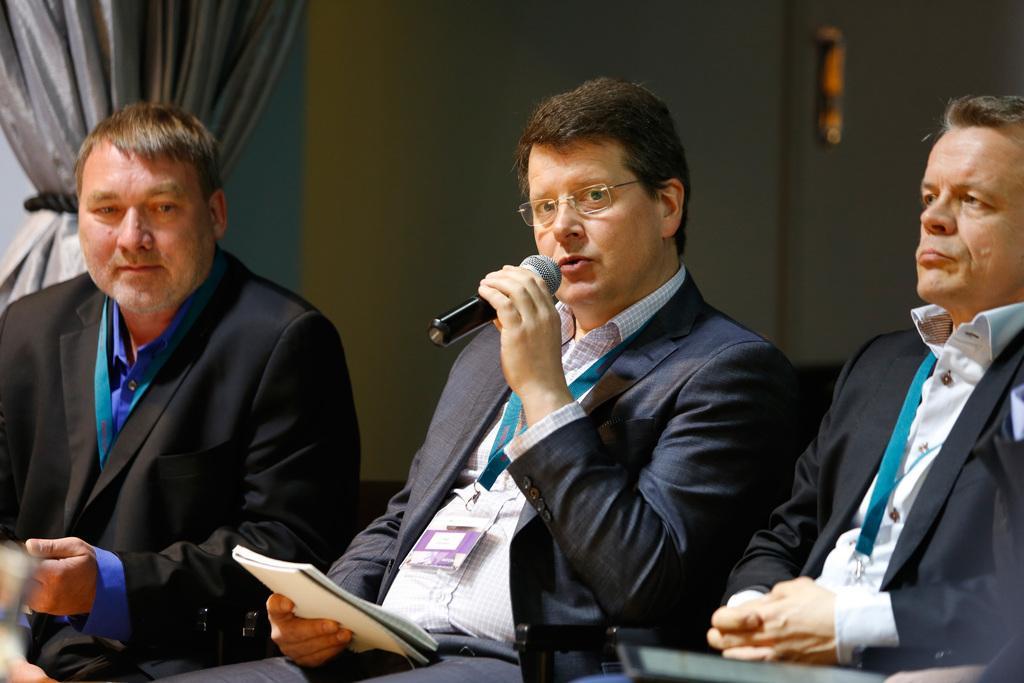How would you summarize this image in a sentence or two? This image is taken indoors. In the background there is a wall and there is a curtain. On the left side of the image a man is sitting in the chair. On the right side of the image another man is sitting in the chair. In the middle of the image a man is sitting in the chair and he is holding a mic and a book in his hands and he is talking. 